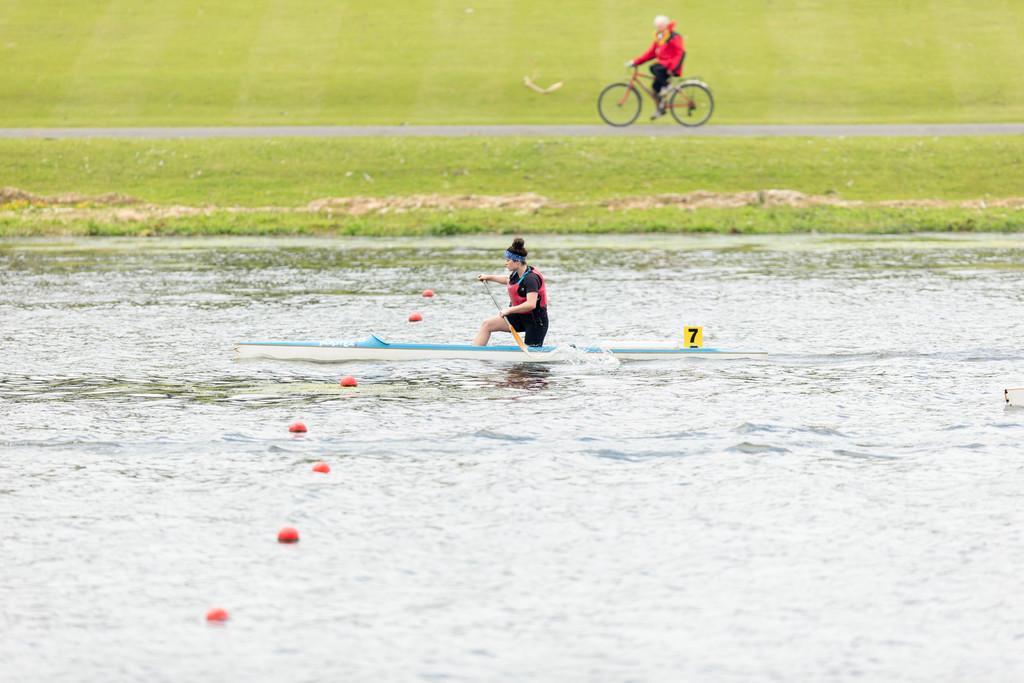Describe this image in one or two sentences. In this picture there is a man riding a small boat in the river water. Behind there is a grass farm and an old man wearing red jacket and riding a bicycle. 